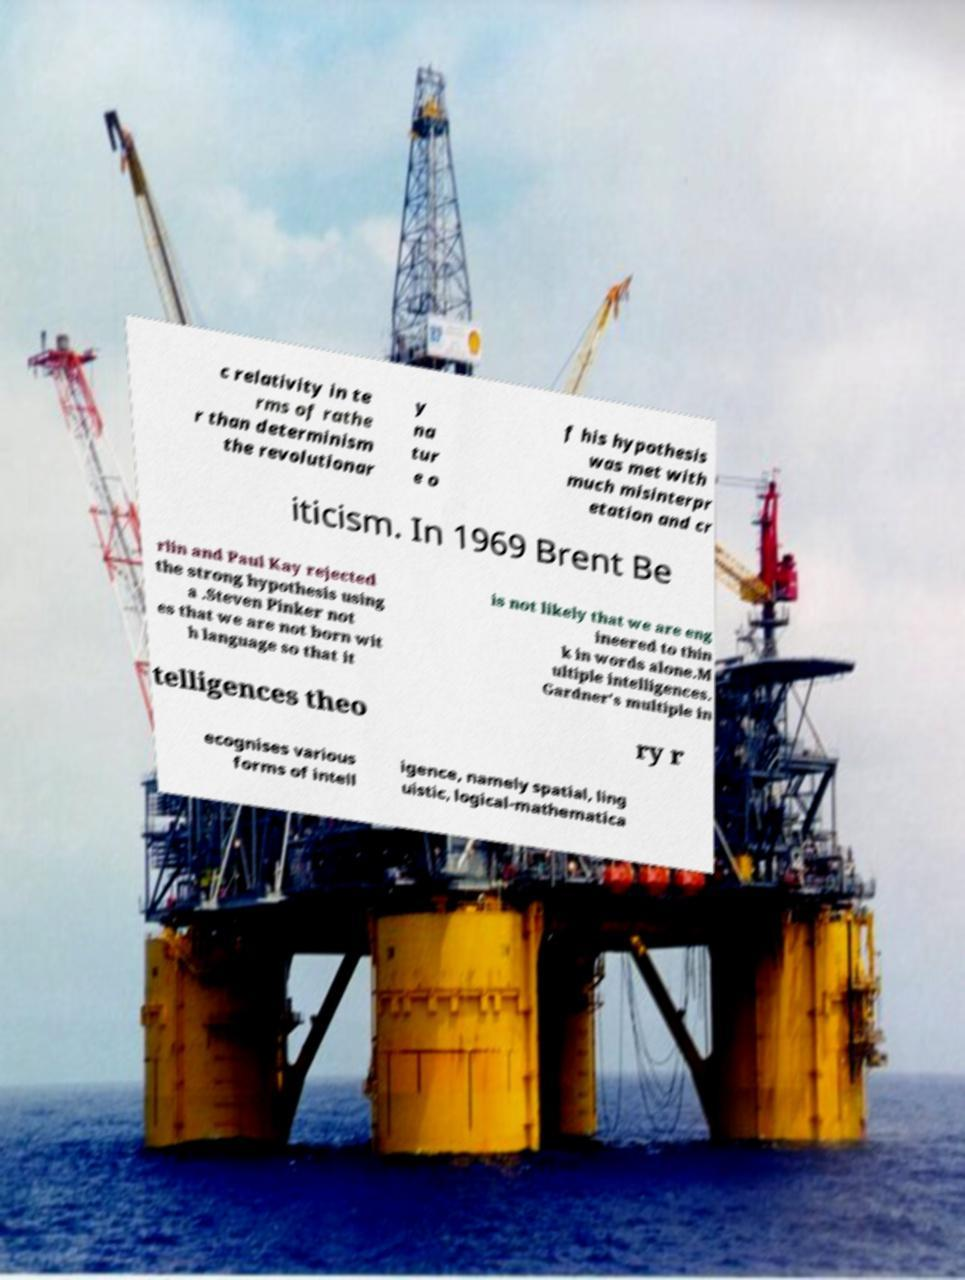Please identify and transcribe the text found in this image. c relativity in te rms of rathe r than determinism the revolutionar y na tur e o f his hypothesis was met with much misinterpr etation and cr iticism. In 1969 Brent Be rlin and Paul Kay rejected the strong hypothesis using a .Steven Pinker not es that we are not born wit h language so that it is not likely that we are eng ineered to thin k in words alone.M ultiple intelligences. Gardner's multiple in telligences theo ry r ecognises various forms of intell igence, namely spatial, ling uistic, logical-mathematica 